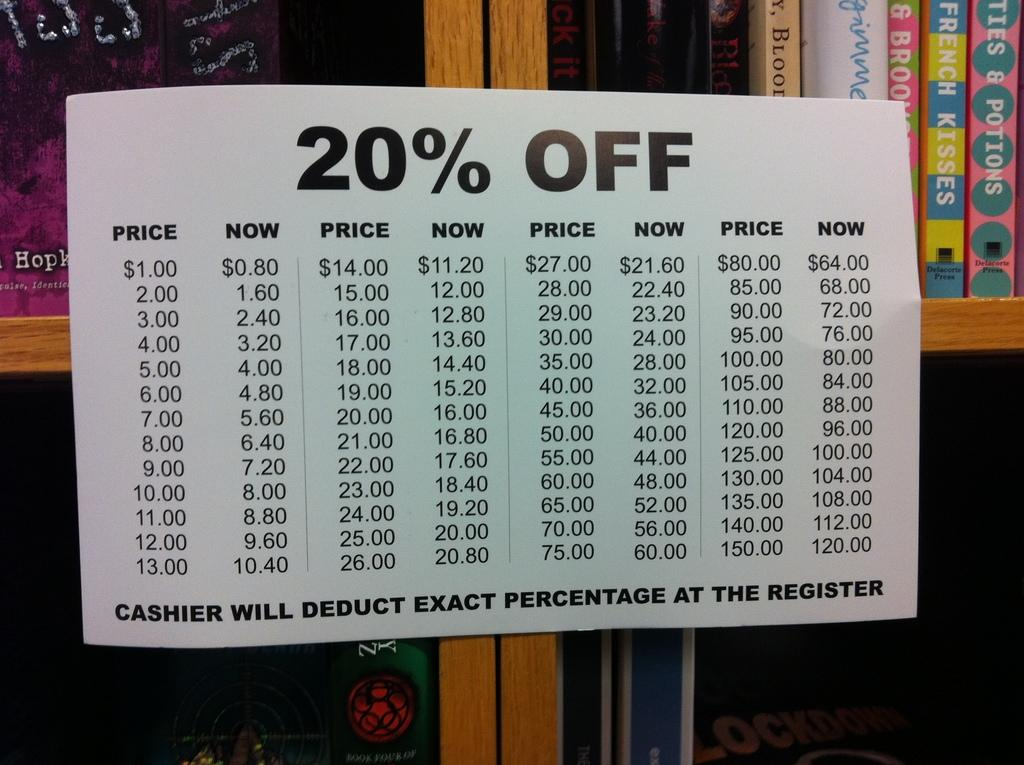<image>
Present a compact description of the photo's key features. A sign on a book shelf that says 20% off. 